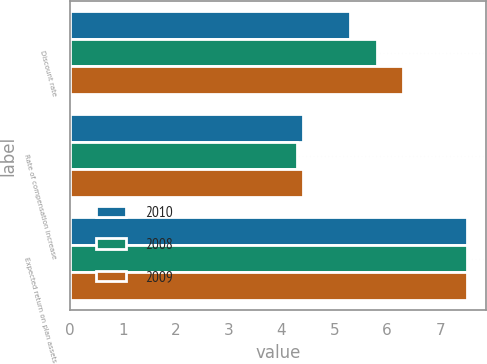<chart> <loc_0><loc_0><loc_500><loc_500><stacked_bar_chart><ecel><fcel>Discount rate<fcel>Rate of compensation increase<fcel>Expected return on plan assets<nl><fcel>2010<fcel>5.3<fcel>4.4<fcel>7.5<nl><fcel>2008<fcel>5.8<fcel>4.3<fcel>7.5<nl><fcel>2009<fcel>6.3<fcel>4.4<fcel>7.5<nl></chart> 